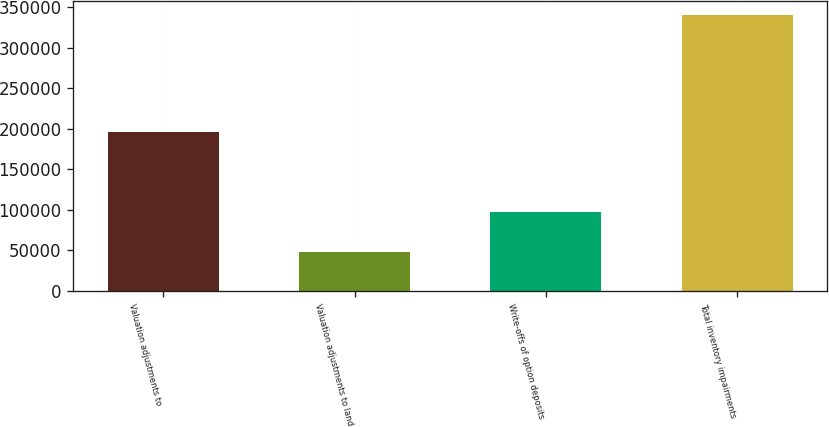Convert chart to OTSL. <chart><loc_0><loc_0><loc_500><loc_500><bar_chart><fcel>Valuation adjustments to<fcel>Valuation adjustments to land<fcel>Write-offs of option deposits<fcel>Total inventory impairments<nl><fcel>195518<fcel>47791<fcel>97172<fcel>340481<nl></chart> 